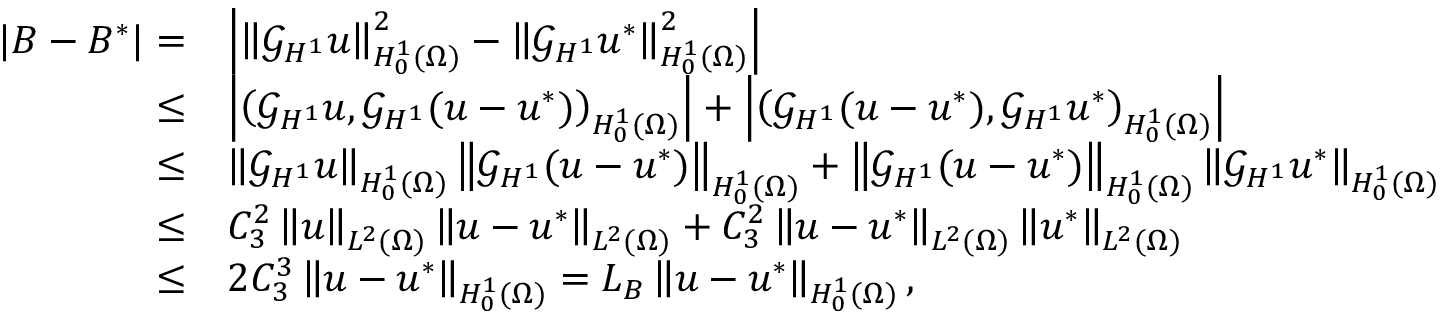<formula> <loc_0><loc_0><loc_500><loc_500>\begin{array} { r l } { | B - B ^ { * } | = } & { \left | \left \| \mathcal { G } _ { H ^ { 1 } } u \right \| _ { H _ { 0 } ^ { 1 } ( \Omega ) } ^ { 2 } - \left \| \mathcal { G } _ { H ^ { 1 } } u ^ { * } \right \| _ { H _ { 0 } ^ { 1 } ( \Omega ) } ^ { 2 } \right | } \\ { \leq } & { \left | \left ( \mathcal { G } _ { H ^ { 1 } } u , \mathcal { G } _ { H ^ { 1 } } ( u - u ^ { * } ) \right ) _ { H _ { 0 } ^ { 1 } ( \Omega ) } \right | + \left | \left ( \mathcal { G } _ { H ^ { 1 } } ( u - u ^ { * } ) , \mathcal { G } _ { H ^ { 1 } } u ^ { * } \right ) _ { H _ { 0 } ^ { 1 } ( \Omega ) } \right | } \\ { \leq } & { \left \| \mathcal { G } _ { H ^ { 1 } } u \right \| _ { H _ { 0 } ^ { 1 } ( \Omega ) } \left \| \mathcal { G } _ { H ^ { 1 } } ( u - u ^ { * } ) \right \| _ { H _ { 0 } ^ { 1 } ( \Omega ) } + \left \| \mathcal { G } _ { H ^ { 1 } } ( u - u ^ { * } ) \right \| _ { H _ { 0 } ^ { 1 } ( \Omega ) } \left \| \mathcal { G } _ { H ^ { 1 } } u ^ { * } \right \| _ { H _ { 0 } ^ { 1 } ( \Omega ) } } \\ { \leq } & { C _ { 3 } ^ { 2 } \left \| u \right \| _ { L ^ { 2 } ( \Omega ) } \left \| u - u ^ { * } \right \| _ { L ^ { 2 } ( \Omega ) } + C _ { 3 } ^ { 2 } \left \| u - u ^ { * } \right \| _ { L ^ { 2 } ( \Omega ) } \left \| u ^ { * } \right \| _ { L ^ { 2 } ( \Omega ) } } \\ { \leq } & { 2 C _ { 3 } ^ { 3 } \left \| u - u ^ { * } \right \| _ { H _ { 0 } ^ { 1 } ( \Omega ) } = L _ { B } \left \| u - u ^ { * } \right \| _ { H _ { 0 } ^ { 1 } ( \Omega ) } , } \end{array}</formula> 